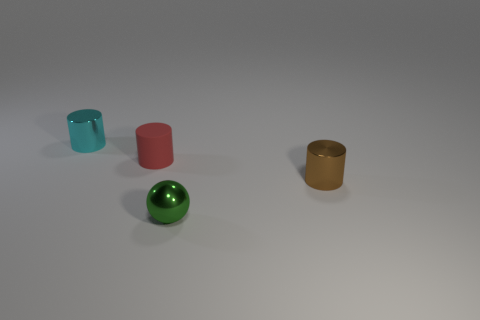Is there anything else that is the same material as the red cylinder?
Give a very brief answer. No. Are the brown thing and the small red cylinder that is to the left of the sphere made of the same material?
Ensure brevity in your answer.  No. How many cylinders are either small brown metallic things or tiny cyan metal objects?
Provide a succinct answer. 2. What number of metallic objects are either green things or brown cylinders?
Provide a succinct answer. 2. There is a cyan metallic object that is the same shape as the small brown thing; what is its size?
Your answer should be compact. Small. There is a brown cylinder; does it have the same size as the shiny thing that is behind the small brown shiny cylinder?
Offer a terse response. Yes. There is a metallic object to the right of the green shiny thing; what is its shape?
Make the answer very short. Cylinder. There is a small shiny cylinder left of the tiny cylinder to the right of the red matte cylinder; what is its color?
Offer a terse response. Cyan. There is a tiny rubber thing that is the same shape as the small cyan shiny thing; what is its color?
Your answer should be compact. Red. What number of tiny matte cylinders are the same color as the tiny sphere?
Ensure brevity in your answer.  0. 